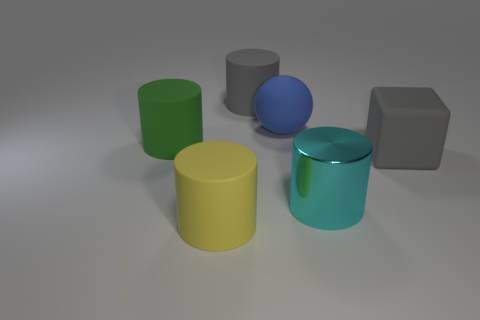What is the color of the other metallic thing that is the same shape as the large green object?
Offer a terse response. Cyan. Is the shape of the yellow object the same as the gray rubber object to the left of the block?
Your answer should be very brief. Yes. What size is the green object that is the same shape as the yellow matte object?
Provide a short and direct response. Large. Are there any cyan rubber spheres of the same size as the green rubber thing?
Make the answer very short. No. Do the big rubber ball and the big block have the same color?
Your answer should be compact. No. What color is the rubber cylinder in front of the big gray matte thing that is right of the large metal thing?
Offer a terse response. Yellow. What number of big things are in front of the large gray matte block and behind the large blue rubber thing?
Provide a short and direct response. 0. How many big gray rubber things have the same shape as the large yellow rubber object?
Your response must be concise. 1. Is the material of the big cyan cylinder the same as the big gray cylinder?
Your response must be concise. No. What is the shape of the big gray object on the right side of the big gray object behind the matte block?
Provide a short and direct response. Cube. 